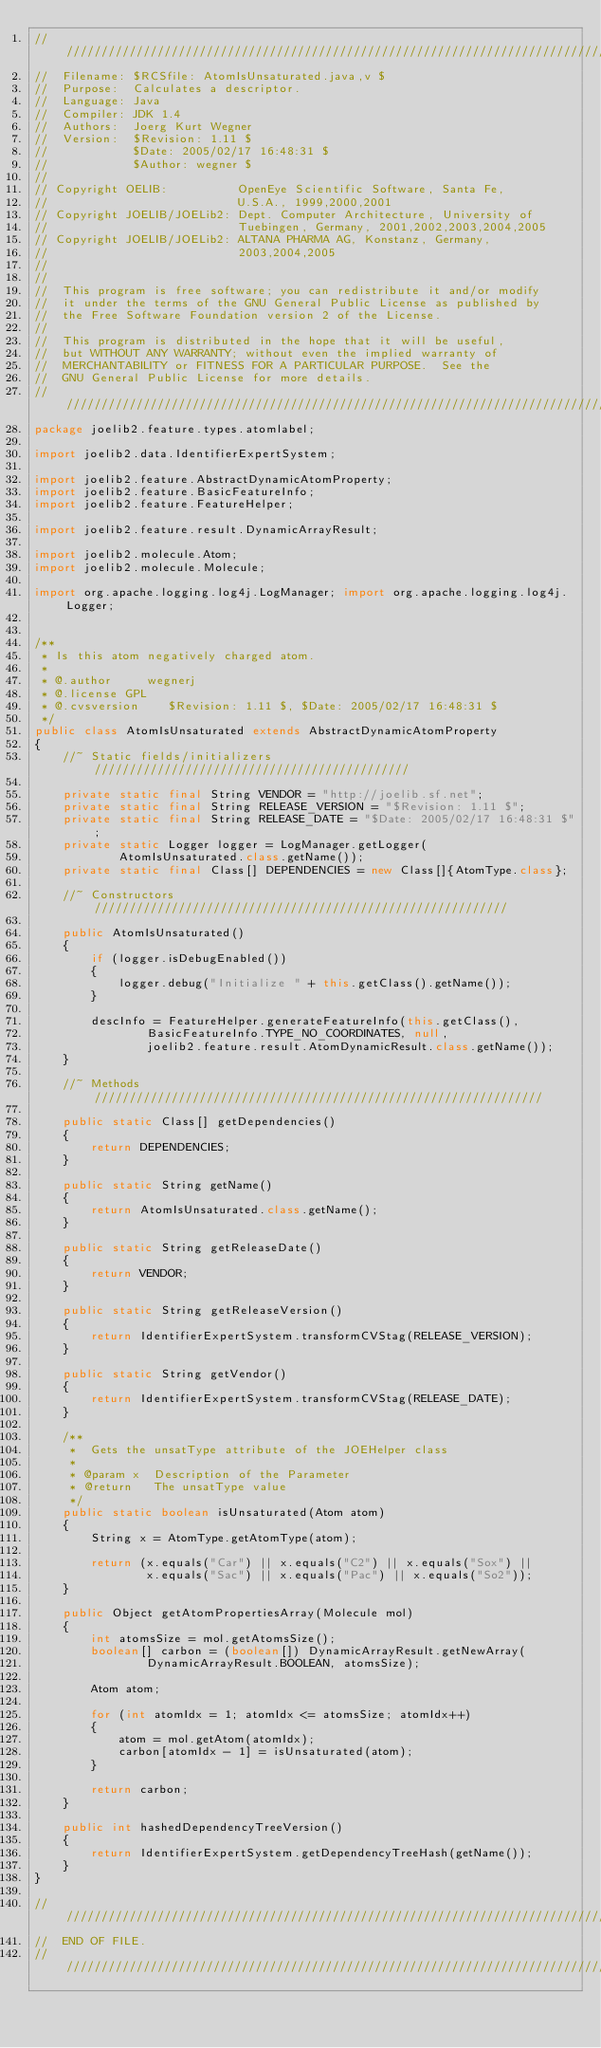<code> <loc_0><loc_0><loc_500><loc_500><_Java_>///////////////////////////////////////////////////////////////////////////////
//  Filename: $RCSfile: AtomIsUnsaturated.java,v $
//  Purpose:  Calculates a descriptor.
//  Language: Java
//  Compiler: JDK 1.4
//  Authors:  Joerg Kurt Wegner
//  Version:  $Revision: 1.11 $
//            $Date: 2005/02/17 16:48:31 $
//            $Author: wegner $
//
// Copyright OELIB:          OpenEye Scientific Software, Santa Fe,
//                           U.S.A., 1999,2000,2001
// Copyright JOELIB/JOELib2: Dept. Computer Architecture, University of
//                           Tuebingen, Germany, 2001,2002,2003,2004,2005
// Copyright JOELIB/JOELib2: ALTANA PHARMA AG, Konstanz, Germany,
//                           2003,2004,2005
//
//
//  This program is free software; you can redistribute it and/or modify
//  it under the terms of the GNU General Public License as published by
//  the Free Software Foundation version 2 of the License.
//
//  This program is distributed in the hope that it will be useful,
//  but WITHOUT ANY WARRANTY; without even the implied warranty of
//  MERCHANTABILITY or FITNESS FOR A PARTICULAR PURPOSE.  See the
//  GNU General Public License for more details.
///////////////////////////////////////////////////////////////////////////////
package joelib2.feature.types.atomlabel;

import joelib2.data.IdentifierExpertSystem;

import joelib2.feature.AbstractDynamicAtomProperty;
import joelib2.feature.BasicFeatureInfo;
import joelib2.feature.FeatureHelper;

import joelib2.feature.result.DynamicArrayResult;

import joelib2.molecule.Atom;
import joelib2.molecule.Molecule;

import org.apache.logging.log4j.LogManager; import org.apache.logging.log4j.Logger;


/**
 * Is this atom negatively charged atom.
 *
 * @.author     wegnerj
 * @.license GPL
 * @.cvsversion    $Revision: 1.11 $, $Date: 2005/02/17 16:48:31 $
 */
public class AtomIsUnsaturated extends AbstractDynamicAtomProperty
{
    //~ Static fields/initializers /////////////////////////////////////////////

    private static final String VENDOR = "http://joelib.sf.net";
    private static final String RELEASE_VERSION = "$Revision: 1.11 $";
    private static final String RELEASE_DATE = "$Date: 2005/02/17 16:48:31 $";
    private static Logger logger = LogManager.getLogger(
            AtomIsUnsaturated.class.getName());
    private static final Class[] DEPENDENCIES = new Class[]{AtomType.class};

    //~ Constructors ///////////////////////////////////////////////////////////

    public AtomIsUnsaturated()
    {
        if (logger.isDebugEnabled())
        {
            logger.debug("Initialize " + this.getClass().getName());
        }

        descInfo = FeatureHelper.generateFeatureInfo(this.getClass(),
                BasicFeatureInfo.TYPE_NO_COORDINATES, null,
                joelib2.feature.result.AtomDynamicResult.class.getName());
    }

    //~ Methods ////////////////////////////////////////////////////////////////

    public static Class[] getDependencies()
    {
        return DEPENDENCIES;
    }

    public static String getName()
    {
        return AtomIsUnsaturated.class.getName();
    }

    public static String getReleaseDate()
    {
        return VENDOR;
    }

    public static String getReleaseVersion()
    {
        return IdentifierExpertSystem.transformCVStag(RELEASE_VERSION);
    }

    public static String getVendor()
    {
        return IdentifierExpertSystem.transformCVStag(RELEASE_DATE);
    }

    /**
     *  Gets the unsatType attribute of the JOEHelper class
     *
     * @param x  Description of the Parameter
     * @return   The unsatType value
     */
    public static boolean isUnsaturated(Atom atom)
    {
        String x = AtomType.getAtomType(atom);

        return (x.equals("Car") || x.equals("C2") || x.equals("Sox") ||
                x.equals("Sac") || x.equals("Pac") || x.equals("So2"));
    }

    public Object getAtomPropertiesArray(Molecule mol)
    {
        int atomsSize = mol.getAtomsSize();
        boolean[] carbon = (boolean[]) DynamicArrayResult.getNewArray(
                DynamicArrayResult.BOOLEAN, atomsSize);

        Atom atom;

        for (int atomIdx = 1; atomIdx <= atomsSize; atomIdx++)
        {
            atom = mol.getAtom(atomIdx);
            carbon[atomIdx - 1] = isUnsaturated(atom);
        }

        return carbon;
    }

    public int hashedDependencyTreeVersion()
    {
        return IdentifierExpertSystem.getDependencyTreeHash(getName());
    }
}

///////////////////////////////////////////////////////////////////////////////
//  END OF FILE.
///////////////////////////////////////////////////////////////////////////////
</code> 